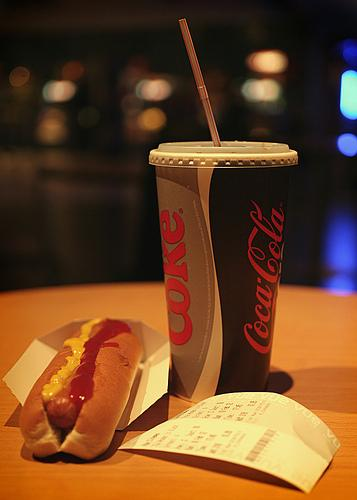Determine if the image prompts any complex reasoning or connections to daily life. The image represents a common scenario from daily life, where people enjoy a casual meal with a hot dog and a refreshing beverage. Count the number of main objects in the image (food item, beverage container, receipt, table). There are four main objects (hot dog, cocacola cup with lid and straw, receipt, and table). What kind of sentiment or emotion can be associated with the image? The image evokes a sense of hunger, satisfaction, or casual enjoyment. What is the color and type of the straw in the image, and does it have any specific characteristics? The straw is red and grey and has thin stripes. It's a flexible straw that can bend. What kind of beverage container is in the image, and which logos or words can be seen on it? A cocacola cup made of grey, black, and white plastic with red letters spelling "coke" and the cocacola logo. Identify the main food item on the table and provide a brief description of its appearance and presentation. A hot dog with ketchup and mustard is served in a white cardboard hot dog holder on a brown wood table. Which objects are interacting in the image, especially regarding the beverage container? A flexible red striped straw is inserted into the cocacola cup with a plastic lid on top. Provide a brief description of the primary object in the image and any condiments on it. A hot dog in a bun is topped with red ketchup and yellow mustard. Describe the scene involving the receipt in the image. A white paper receipt is lying on a brown wood table, with blurred lights in the background. Mention the color and material of the table in the image. The table is brown and made of wood. Are the hot dog bun and the hot dog holder made of metal? The hot dog bun mentioned in the given objects list is light brown, and the hot dog holder is white cardboard, not metal. Is the straw in the shape of a spiral, and its color is entirely pink? The straw mentioned in the given objects is not spiral-shaped, and it has red stripes, not completely pink. Is the hot dog green with purple sauce on top? There is no green hot dog with purple sauce in the given objects. Instead, there is a hot dog with mustard and ketchup, and the condiments are red and yellow. Can you see the transparent blue drinking cup with yellow polka dots? There is no transparent blue drinking cup with yellow polka dots in the given objects. The available cup is a gray, black, and white paper cup with red letters and the Coca-Cola logo. Describe what the hot dog is lying on. The hot dog is lying on a brown wooden table in a white cardboard hotdog holder. Which of the following captions best describes the hotdog? (a) a hotdog with ketchup and mustard, (b) a hotdog with mustard, or (c) a hotdog with ketchup. (a) a hotdog with ketchup and mustard Identify the state of the background in the image. The background is blurred with lights. What is covering the hot dog? Ketchup and mustard List the colors present on the straw. Red and grey Choose the correct statement about the table: (a) the table is made of glass, (b) the table is green or (c) the table is brown. (c) the table is brown What kind of lid is on the cup? A white plastic lid Describe the colors of the cup in this image. Black, gray, white, and red What type of table is shown in the image? A light brown wooden table Is the wooden table actually floating mid-air, and it has a bright blue color? The table in the given objects is brown and not floating mid-air. There are no objects mentioning floating items or bright blue colorations. Identify the primary colors present on the hot dog. Red for ketchup and yellow for mustard What color are the cocacola letters on the cup? Red Provide the main characteristics of the hot dog bun. The hot dog bun is big and light brown. Does the hotdog have any condiments on it? If so, what are they? Yes, the hotdog has ketchup and mustard on it. Describe the receipt's appearance. The receipt is white and on a wooden table. State the attributes of the straw in the cup. The straw is thin, has red stripes, and can bend. What is used to hold the hotdog? A white cardboard hotdog holder What is next to the hotdog on the table? A cocacola cup and a receipt Explain what the straw in the cup looks like. The straw has red stripes, can bend, and is red and grey. What are the main objects present on the table? A hotdog, a cocacola cup, and a receipt Is there a huge orange tree in the background of the image? There is no tree mentioned in the given objects. The background consists of blurred lights, and there are no objects mentioning any trees or an orange color. What color is the cup that has a cocacola logo on it? Grey, black, and white 